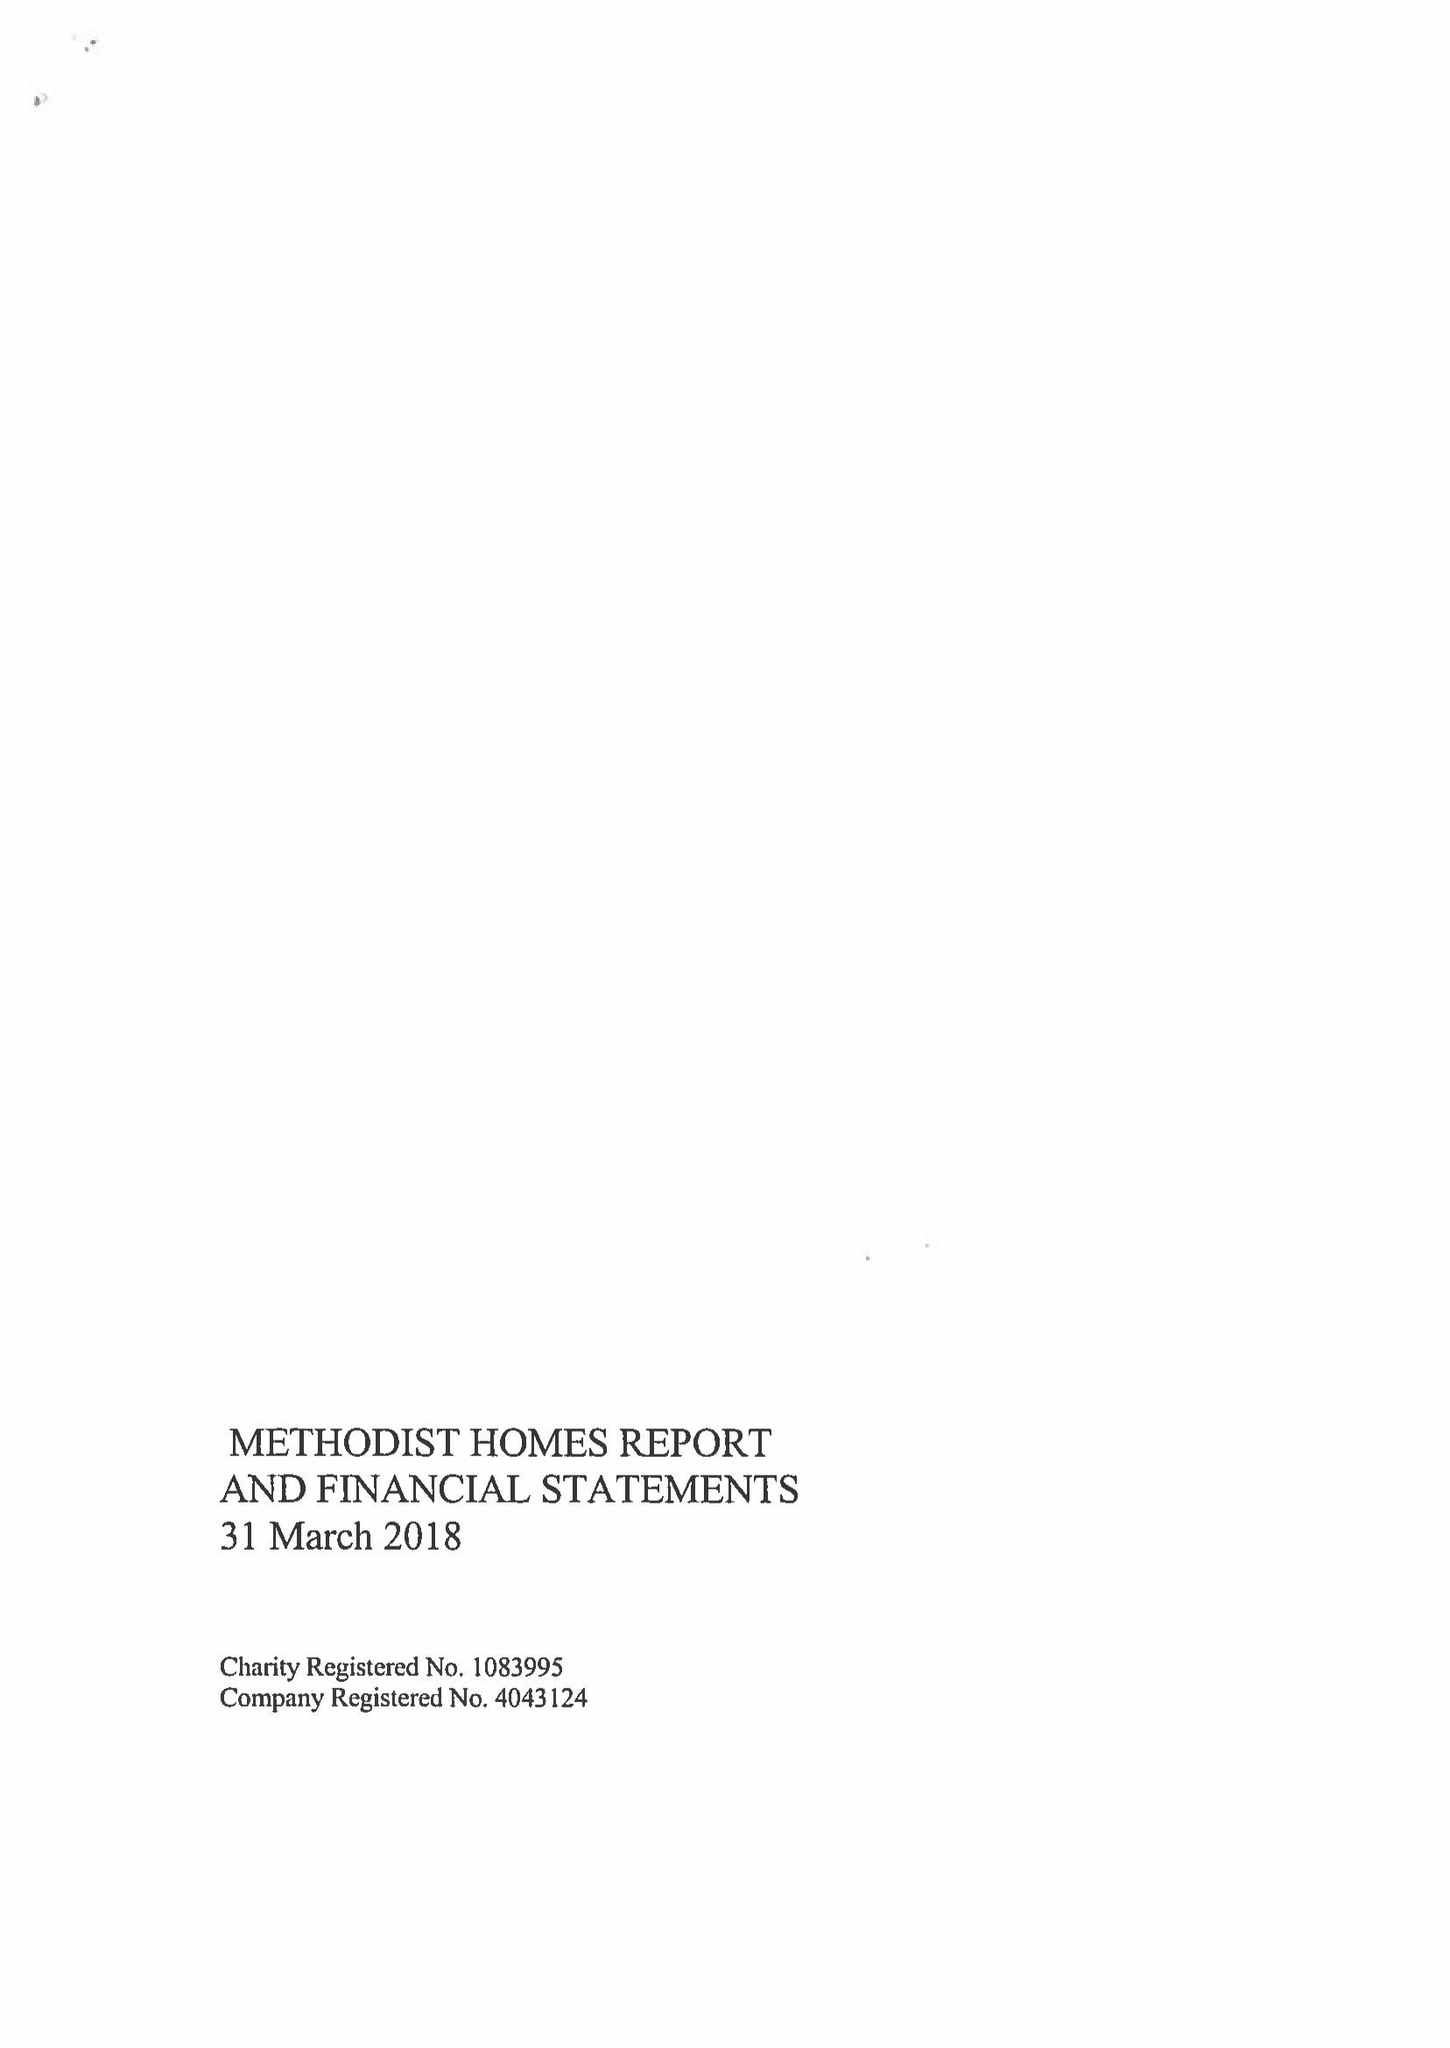What is the value for the address__postcode?
Answer the question using a single word or phrase. DE1 2EQ 